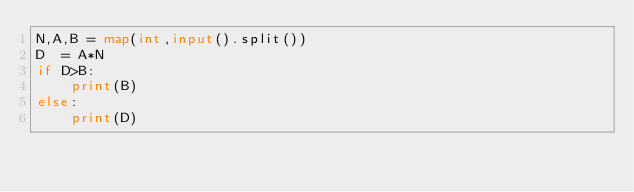Convert code to text. <code><loc_0><loc_0><loc_500><loc_500><_Python_>N,A,B = map(int,input().split())
D  = A*N
if D>B:
    print(B)
else: 
    print(D)</code> 